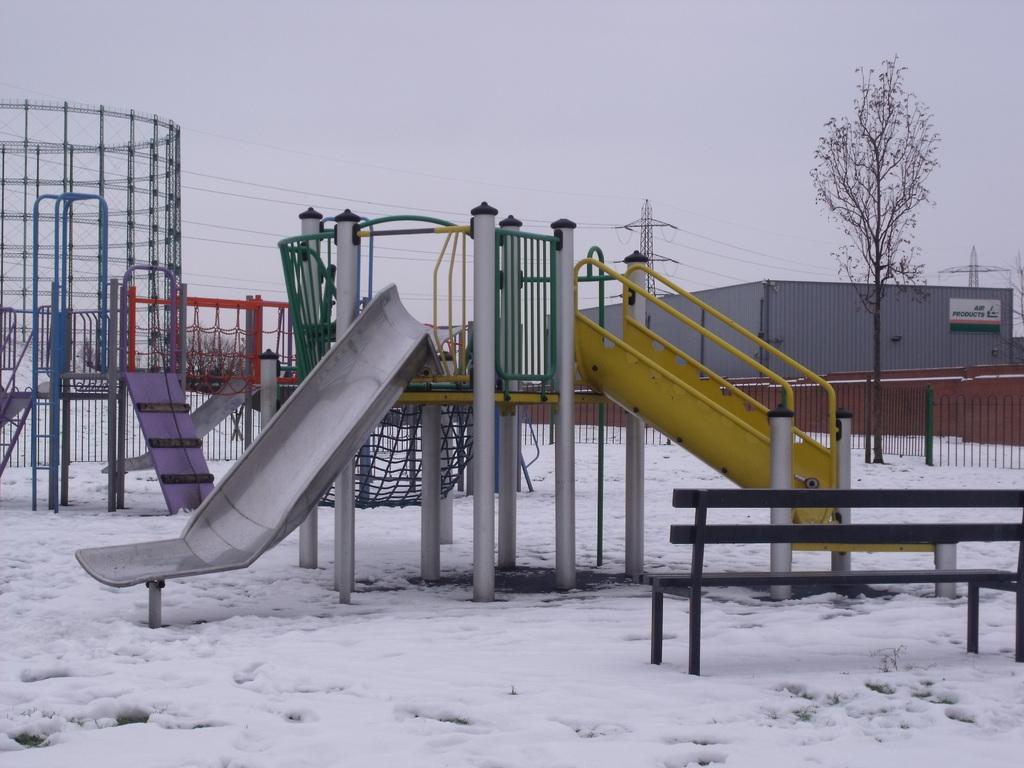Describe this image in one or two sentences. In this image we can see slides on the ground with snow, there is a bench, on the right side of the image there is a fence, tree, building, tower with wires and the sky in the background. 